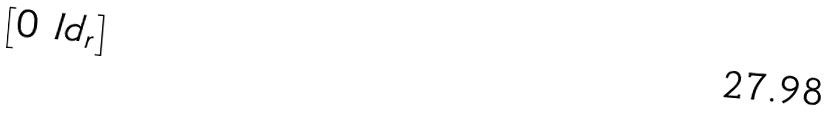Convert formula to latex. <formula><loc_0><loc_0><loc_500><loc_500>\begin{bmatrix} 0 & I d _ { r } \end{bmatrix}</formula> 